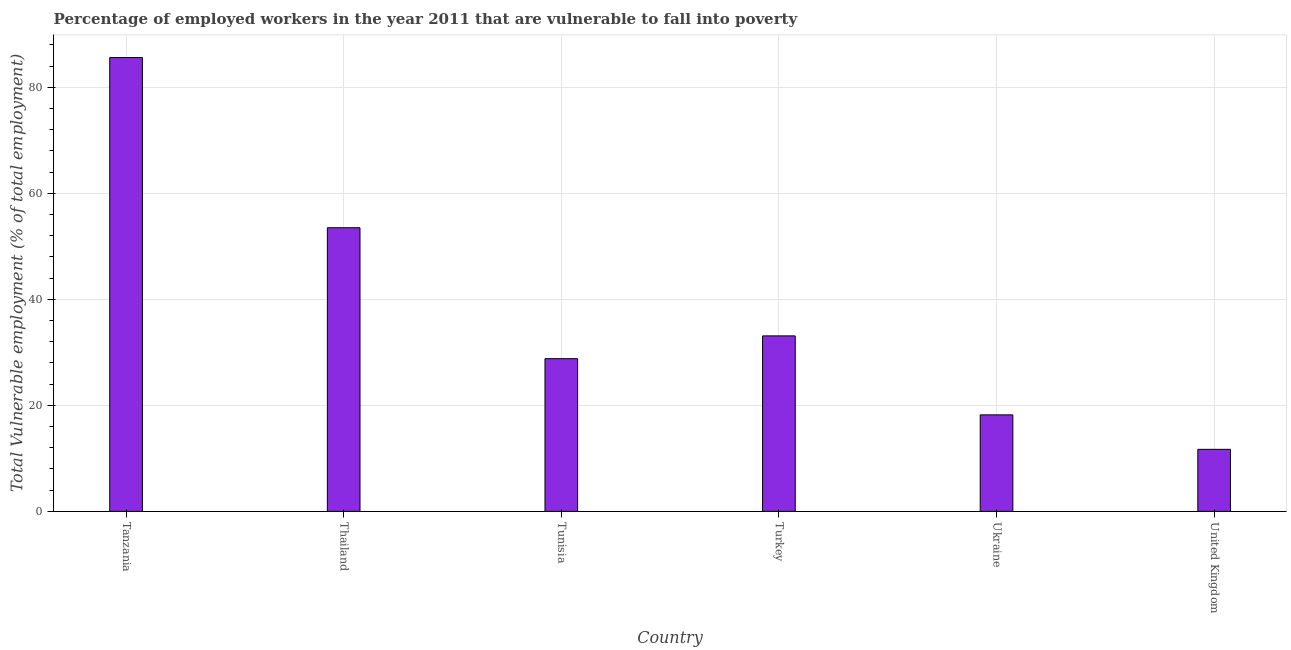What is the title of the graph?
Give a very brief answer. Percentage of employed workers in the year 2011 that are vulnerable to fall into poverty. What is the label or title of the Y-axis?
Offer a terse response. Total Vulnerable employment (% of total employment). What is the total vulnerable employment in Thailand?
Offer a terse response. 53.5. Across all countries, what is the maximum total vulnerable employment?
Your answer should be very brief. 85.6. Across all countries, what is the minimum total vulnerable employment?
Your answer should be compact. 11.7. In which country was the total vulnerable employment maximum?
Keep it short and to the point. Tanzania. What is the sum of the total vulnerable employment?
Provide a short and direct response. 230.9. What is the difference between the total vulnerable employment in Tunisia and Turkey?
Give a very brief answer. -4.3. What is the average total vulnerable employment per country?
Keep it short and to the point. 38.48. What is the median total vulnerable employment?
Make the answer very short. 30.95. What is the ratio of the total vulnerable employment in Tanzania to that in Tunisia?
Your answer should be very brief. 2.97. What is the difference between the highest and the second highest total vulnerable employment?
Your answer should be very brief. 32.1. Is the sum of the total vulnerable employment in Thailand and Turkey greater than the maximum total vulnerable employment across all countries?
Provide a succinct answer. Yes. What is the difference between the highest and the lowest total vulnerable employment?
Offer a terse response. 73.9. Are all the bars in the graph horizontal?
Offer a very short reply. No. What is the Total Vulnerable employment (% of total employment) in Tanzania?
Keep it short and to the point. 85.6. What is the Total Vulnerable employment (% of total employment) in Thailand?
Give a very brief answer. 53.5. What is the Total Vulnerable employment (% of total employment) in Tunisia?
Provide a succinct answer. 28.8. What is the Total Vulnerable employment (% of total employment) in Turkey?
Your answer should be compact. 33.1. What is the Total Vulnerable employment (% of total employment) of Ukraine?
Your response must be concise. 18.2. What is the Total Vulnerable employment (% of total employment) of United Kingdom?
Provide a short and direct response. 11.7. What is the difference between the Total Vulnerable employment (% of total employment) in Tanzania and Thailand?
Offer a terse response. 32.1. What is the difference between the Total Vulnerable employment (% of total employment) in Tanzania and Tunisia?
Make the answer very short. 56.8. What is the difference between the Total Vulnerable employment (% of total employment) in Tanzania and Turkey?
Keep it short and to the point. 52.5. What is the difference between the Total Vulnerable employment (% of total employment) in Tanzania and Ukraine?
Offer a very short reply. 67.4. What is the difference between the Total Vulnerable employment (% of total employment) in Tanzania and United Kingdom?
Provide a succinct answer. 73.9. What is the difference between the Total Vulnerable employment (% of total employment) in Thailand and Tunisia?
Offer a very short reply. 24.7. What is the difference between the Total Vulnerable employment (% of total employment) in Thailand and Turkey?
Keep it short and to the point. 20.4. What is the difference between the Total Vulnerable employment (% of total employment) in Thailand and Ukraine?
Your response must be concise. 35.3. What is the difference between the Total Vulnerable employment (% of total employment) in Thailand and United Kingdom?
Keep it short and to the point. 41.8. What is the difference between the Total Vulnerable employment (% of total employment) in Tunisia and Turkey?
Make the answer very short. -4.3. What is the difference between the Total Vulnerable employment (% of total employment) in Tunisia and Ukraine?
Provide a short and direct response. 10.6. What is the difference between the Total Vulnerable employment (% of total employment) in Tunisia and United Kingdom?
Keep it short and to the point. 17.1. What is the difference between the Total Vulnerable employment (% of total employment) in Turkey and United Kingdom?
Your response must be concise. 21.4. What is the ratio of the Total Vulnerable employment (% of total employment) in Tanzania to that in Tunisia?
Provide a succinct answer. 2.97. What is the ratio of the Total Vulnerable employment (% of total employment) in Tanzania to that in Turkey?
Your answer should be compact. 2.59. What is the ratio of the Total Vulnerable employment (% of total employment) in Tanzania to that in Ukraine?
Offer a very short reply. 4.7. What is the ratio of the Total Vulnerable employment (% of total employment) in Tanzania to that in United Kingdom?
Your answer should be very brief. 7.32. What is the ratio of the Total Vulnerable employment (% of total employment) in Thailand to that in Tunisia?
Your answer should be compact. 1.86. What is the ratio of the Total Vulnerable employment (% of total employment) in Thailand to that in Turkey?
Your response must be concise. 1.62. What is the ratio of the Total Vulnerable employment (% of total employment) in Thailand to that in Ukraine?
Offer a very short reply. 2.94. What is the ratio of the Total Vulnerable employment (% of total employment) in Thailand to that in United Kingdom?
Your answer should be very brief. 4.57. What is the ratio of the Total Vulnerable employment (% of total employment) in Tunisia to that in Turkey?
Offer a very short reply. 0.87. What is the ratio of the Total Vulnerable employment (% of total employment) in Tunisia to that in Ukraine?
Your answer should be very brief. 1.58. What is the ratio of the Total Vulnerable employment (% of total employment) in Tunisia to that in United Kingdom?
Ensure brevity in your answer.  2.46. What is the ratio of the Total Vulnerable employment (% of total employment) in Turkey to that in Ukraine?
Provide a succinct answer. 1.82. What is the ratio of the Total Vulnerable employment (% of total employment) in Turkey to that in United Kingdom?
Make the answer very short. 2.83. What is the ratio of the Total Vulnerable employment (% of total employment) in Ukraine to that in United Kingdom?
Your answer should be compact. 1.56. 